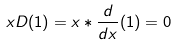<formula> <loc_0><loc_0><loc_500><loc_500>x D ( 1 ) = x * \frac { d } { d x } ( 1 ) = 0</formula> 